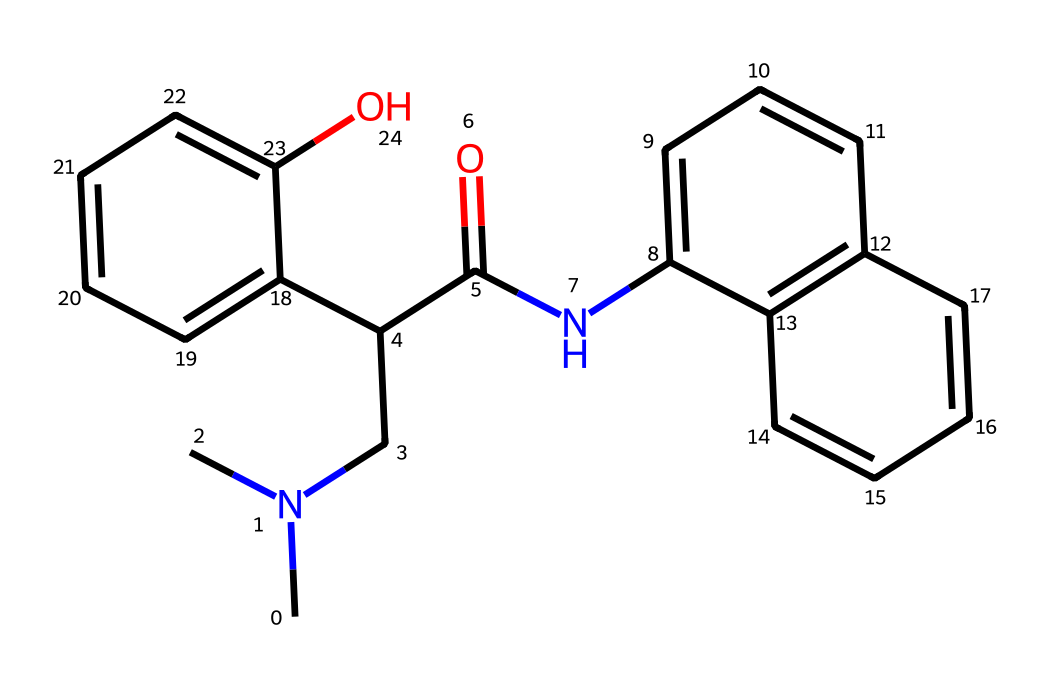What is the molecular formula of metoclopramide? To determine the molecular formula, count the number of each type of atom in the SMILES representation. The breakdown is: C=13, H=18, N=2, O=1. Therefore, the molecular formula is C13H18N2O.
Answer: C13H18N2O How many nitrogen atoms are present in metoclopramide's structure? Looking at the SMILES representation, identify the nitrogen (N) symbols. There are two nitrogen atoms represented, indicating that the structure contains two nitrogen atoms.
Answer: 2 What functional groups are present in metoclopramide? By analyzing the SMILES structure, it can be seen that there are amine groups (due to the nitrogen atoms in the chain), a carbonyl group (C=O), and a hydroxyl group (–OH). The presence of these groups identifies the functional groups in the molecule.
Answer: amine, carbonyl, hydroxyl What type of drug is metoclopramide classified as? Metoclopramide is primarily classified as an antiemetic and gastroprokinetic agent, which affects gastric motility and reduces nausea and vomiting. This classification informs about its therapeutic effects based on its chemical structure and interaction with the nervous system.
Answer: antiemetic How does metoclopramide interact with the vagus nerve? The interaction of metoclopramide with the vagus nerve involves its action as a dopamine antagonist, which enhances gastrointestinal motility by affecting the neurotransmission in the vagus nerve pathway. This receptor activity leads to an increase in gastric emptying and reduction of nausea.
Answer: dopamine antagonist What is the role of the hydroxyl group in metoclopramide? The presence of the hydroxyl group (–OH) in metoclopramide contributes to its polarity, which can influence its solubility and bioactivity. Hydroxyl groups often increase the hydrogen-bonding capability, enhancing interaction with biological targets such as receptors in the digestive tract.
Answer: increases polarity 